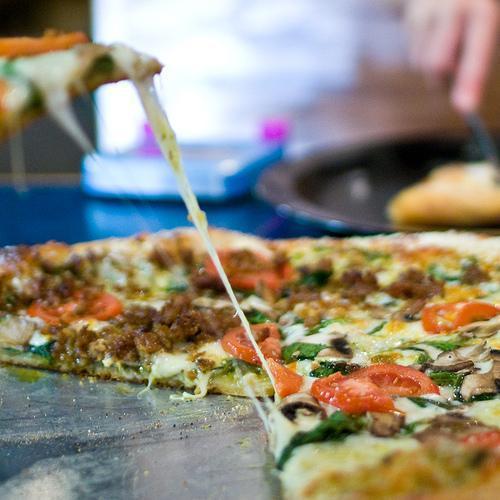How many pizzas are in the picture?
Give a very brief answer. 1. How many slices have been picked?
Give a very brief answer. 2. How many pizzas are visible?
Give a very brief answer. 2. 